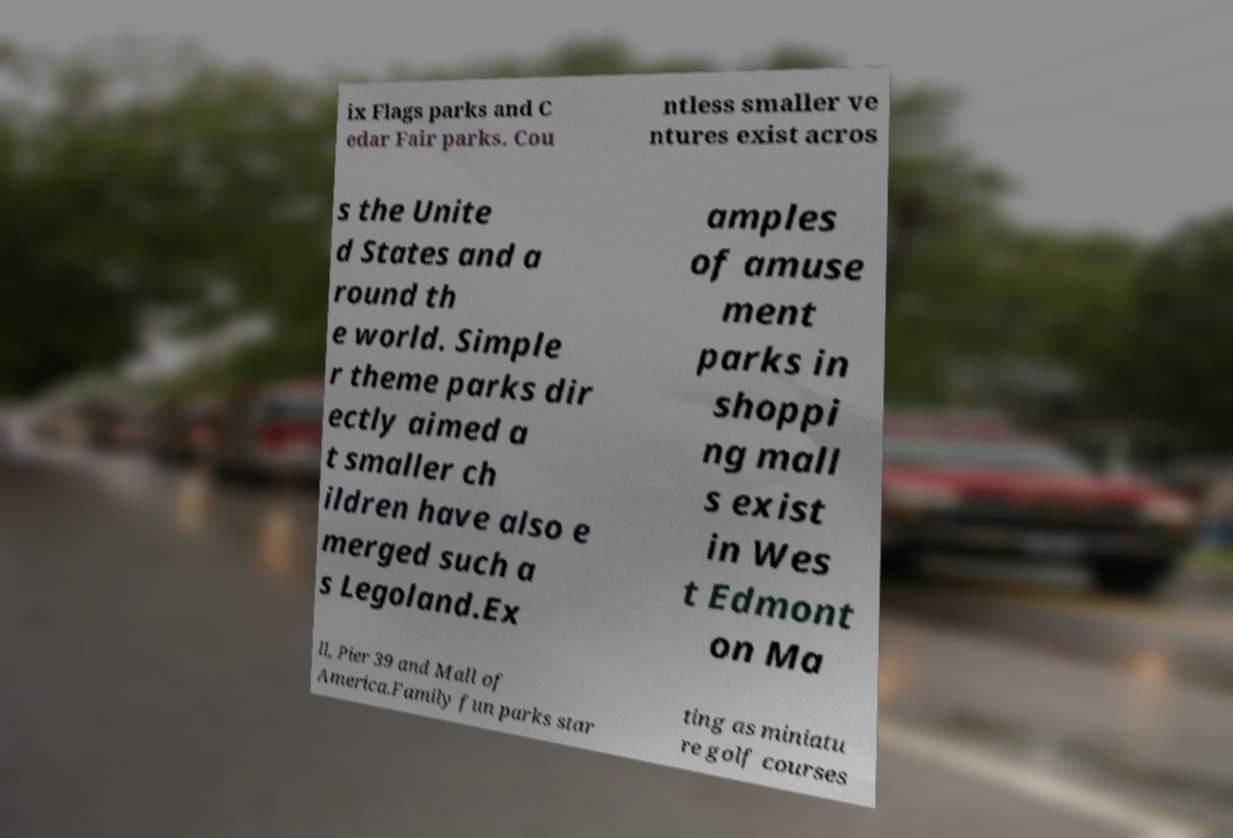Can you read and provide the text displayed in the image?This photo seems to have some interesting text. Can you extract and type it out for me? ix Flags parks and C edar Fair parks. Cou ntless smaller ve ntures exist acros s the Unite d States and a round th e world. Simple r theme parks dir ectly aimed a t smaller ch ildren have also e merged such a s Legoland.Ex amples of amuse ment parks in shoppi ng mall s exist in Wes t Edmont on Ma ll, Pier 39 and Mall of America.Family fun parks star ting as miniatu re golf courses 